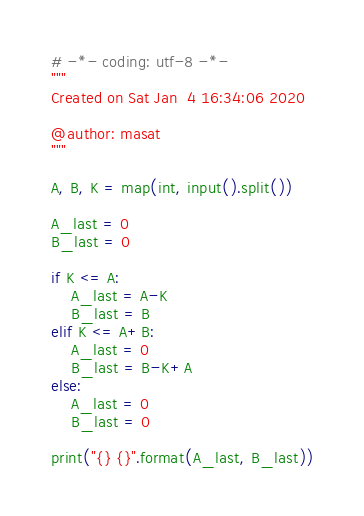Convert code to text. <code><loc_0><loc_0><loc_500><loc_500><_Python_># -*- coding: utf-8 -*-
"""
Created on Sat Jan  4 16:34:06 2020

@author: masat
"""

A, B, K = map(int, input().split())

A_last = 0
B_last = 0

if K <= A:
    A_last = A-K
    B_last = B
elif K <= A+B:
    A_last = 0
    B_last = B-K+A
else:
    A_last = 0
    B_last = 0

print("{} {}".format(A_last, B_last))
</code> 